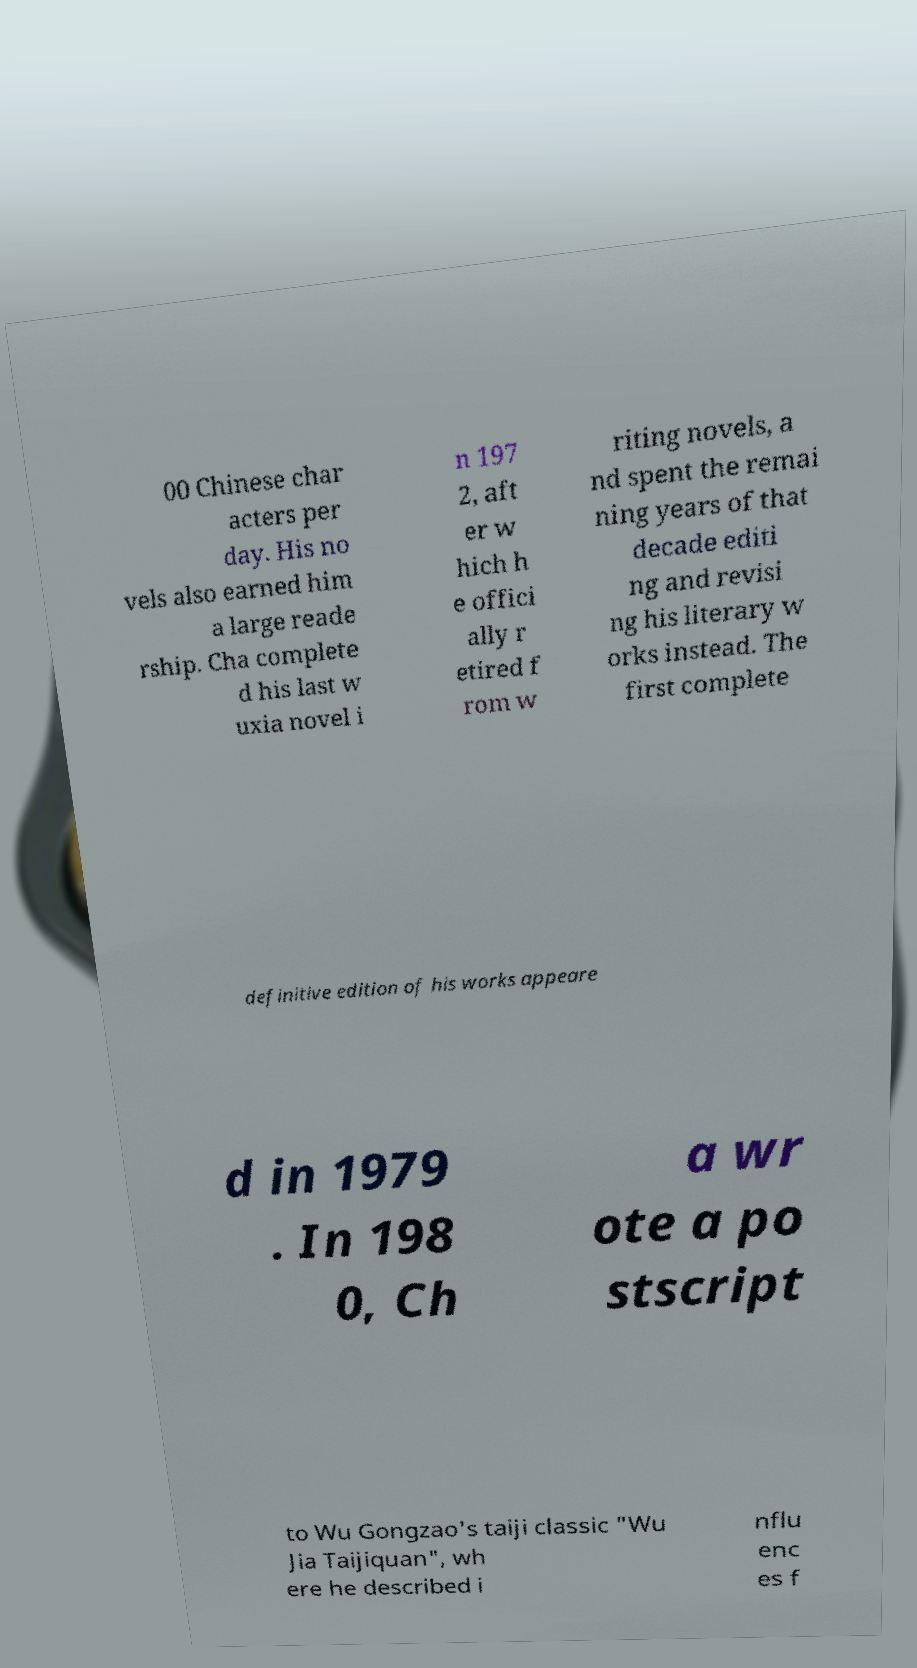Please read and relay the text visible in this image. What does it say? 00 Chinese char acters per day. His no vels also earned him a large reade rship. Cha complete d his last w uxia novel i n 197 2, aft er w hich h e offici ally r etired f rom w riting novels, a nd spent the remai ning years of that decade editi ng and revisi ng his literary w orks instead. The first complete definitive edition of his works appeare d in 1979 . In 198 0, Ch a wr ote a po stscript to Wu Gongzao's taiji classic "Wu Jia Taijiquan", wh ere he described i nflu enc es f 